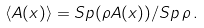Convert formula to latex. <formula><loc_0><loc_0><loc_500><loc_500>\langle { A } ( x ) \rangle = S p ( { \rho } { A } ( x ) ) / S p \, { \rho } \, .</formula> 